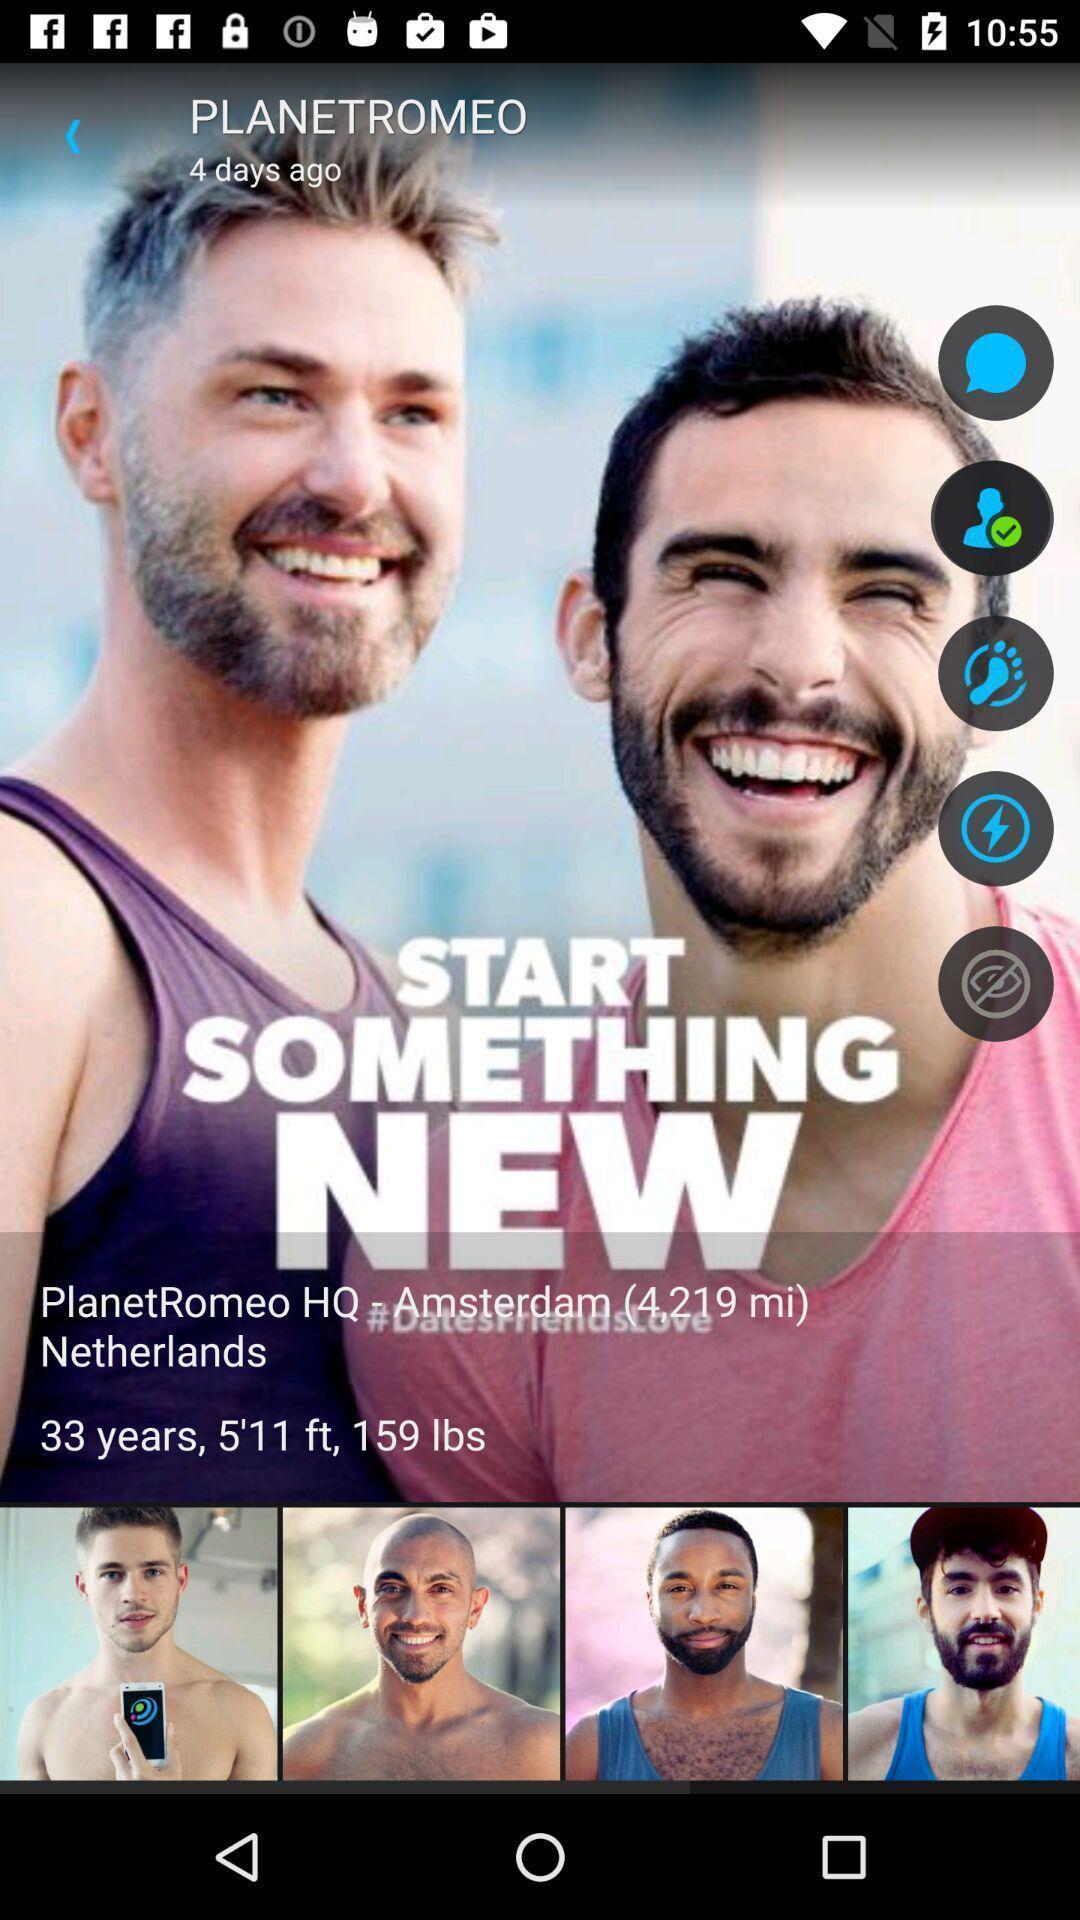Give me a summary of this screen capture. Start something new of planetomeo. 